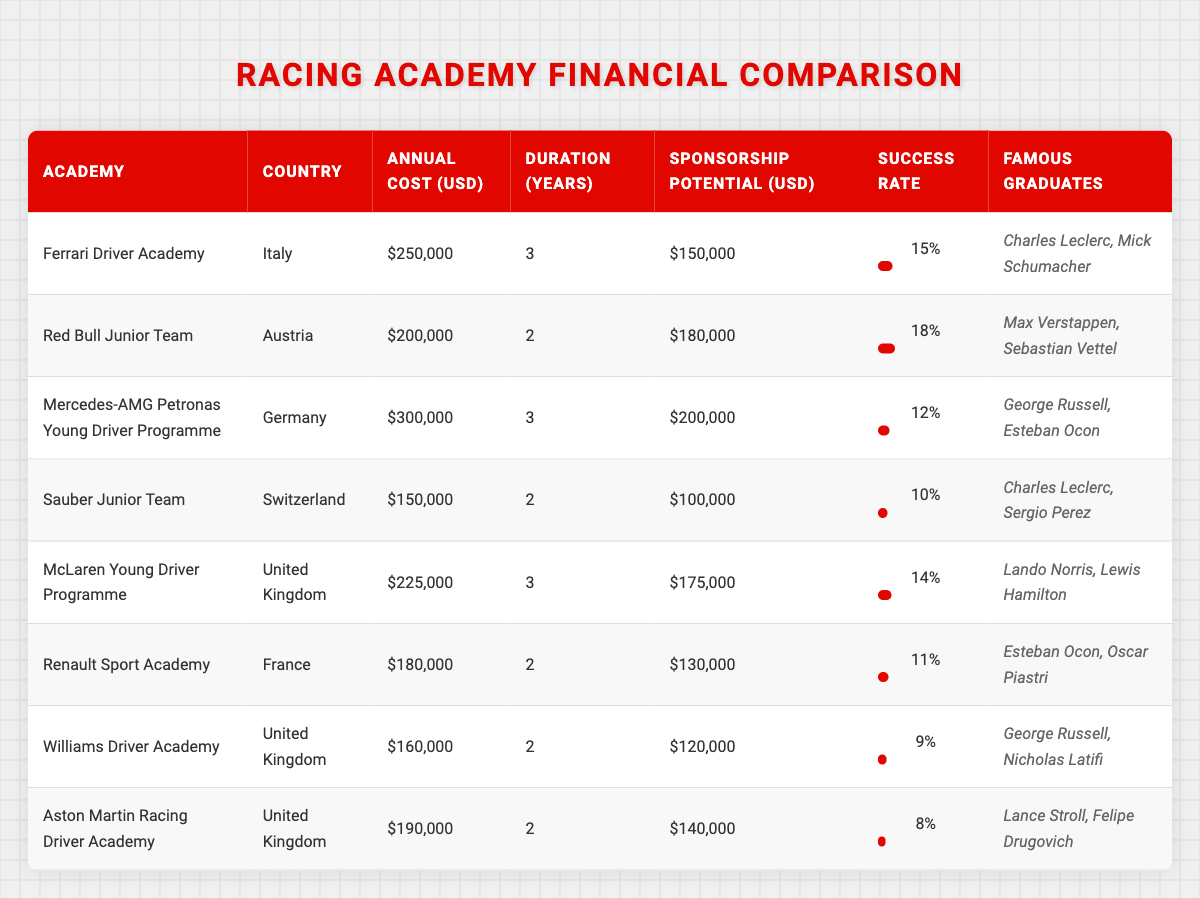What is the annual cost of the Sauber Junior Team? The table lists the Sauber Junior Team under its respective row, and the annual cost mentioned in the table is $150,000.
Answer: $150,000 Which racing academy has the highest success rate? Scanning through the success rate column, the Red Bull Junior Team has the highest listed success rate of 18%.
Answer: Red Bull Junior Team What is the total annual cost of the top three most expensive driver development programs? The three most expensive programs are Mercedes-AMG Petronas ($300,000), Ferrari Driver Academy ($250,000), and McLaren Young Driver Programme ($225,000). Adding these gives $300,000 + $250,000 + $225,000 = $775,000.
Answer: $775,000 Is it true that the Williams Driver Academy has a higher sponsorship potential than the Aston Martin Racing Driver Academy? Comparing the sponsorship potential values, Williams Driver Academy has $120,000, while Aston Martin has $140,000. Therefore, it is false that Williams has a higher sponsorship potential.
Answer: No What is the average duration of the programs listed in the table? The durations are 3, 2, 3, 2, 3, 2, 2, and 2 years respectively. Summing these gives 3 + 2 + 3 + 2 + 3 + 2 + 2 + 2 = 21, and there are 8 programs, so the average is 21 / 8 = 2.625 years.
Answer: 2.625 years Which racing academy located in the United Kingdom has the lowest success rate? Looking at the success rates for United Kingdom programs, Williams Driver Academy has a success rate of 9%, while Aston Martin Racing has 8%. Therefore, Aston Martin Racing has the lowest success rate among UK-based academies.
Answer: Aston Martin Racing What is the sponsorship potential difference between the Mercedes-AMG Petronas Young Driver Programme and the Renault Sport Academy? The Mercedes-AMG Petronas Young Driver Programme has a sponsorship potential of $200,000, while the Renault Sport Academy has $130,000. The difference is $200,000 - $130,000 = $70,000.
Answer: $70,000 How many famous graduates are noted for the Sauber Junior Team? Reviewing the famous graduates listed for the Sauber Junior Team in the table, there are two names: Charles Leclerc and Sergio Perez.
Answer: 2 